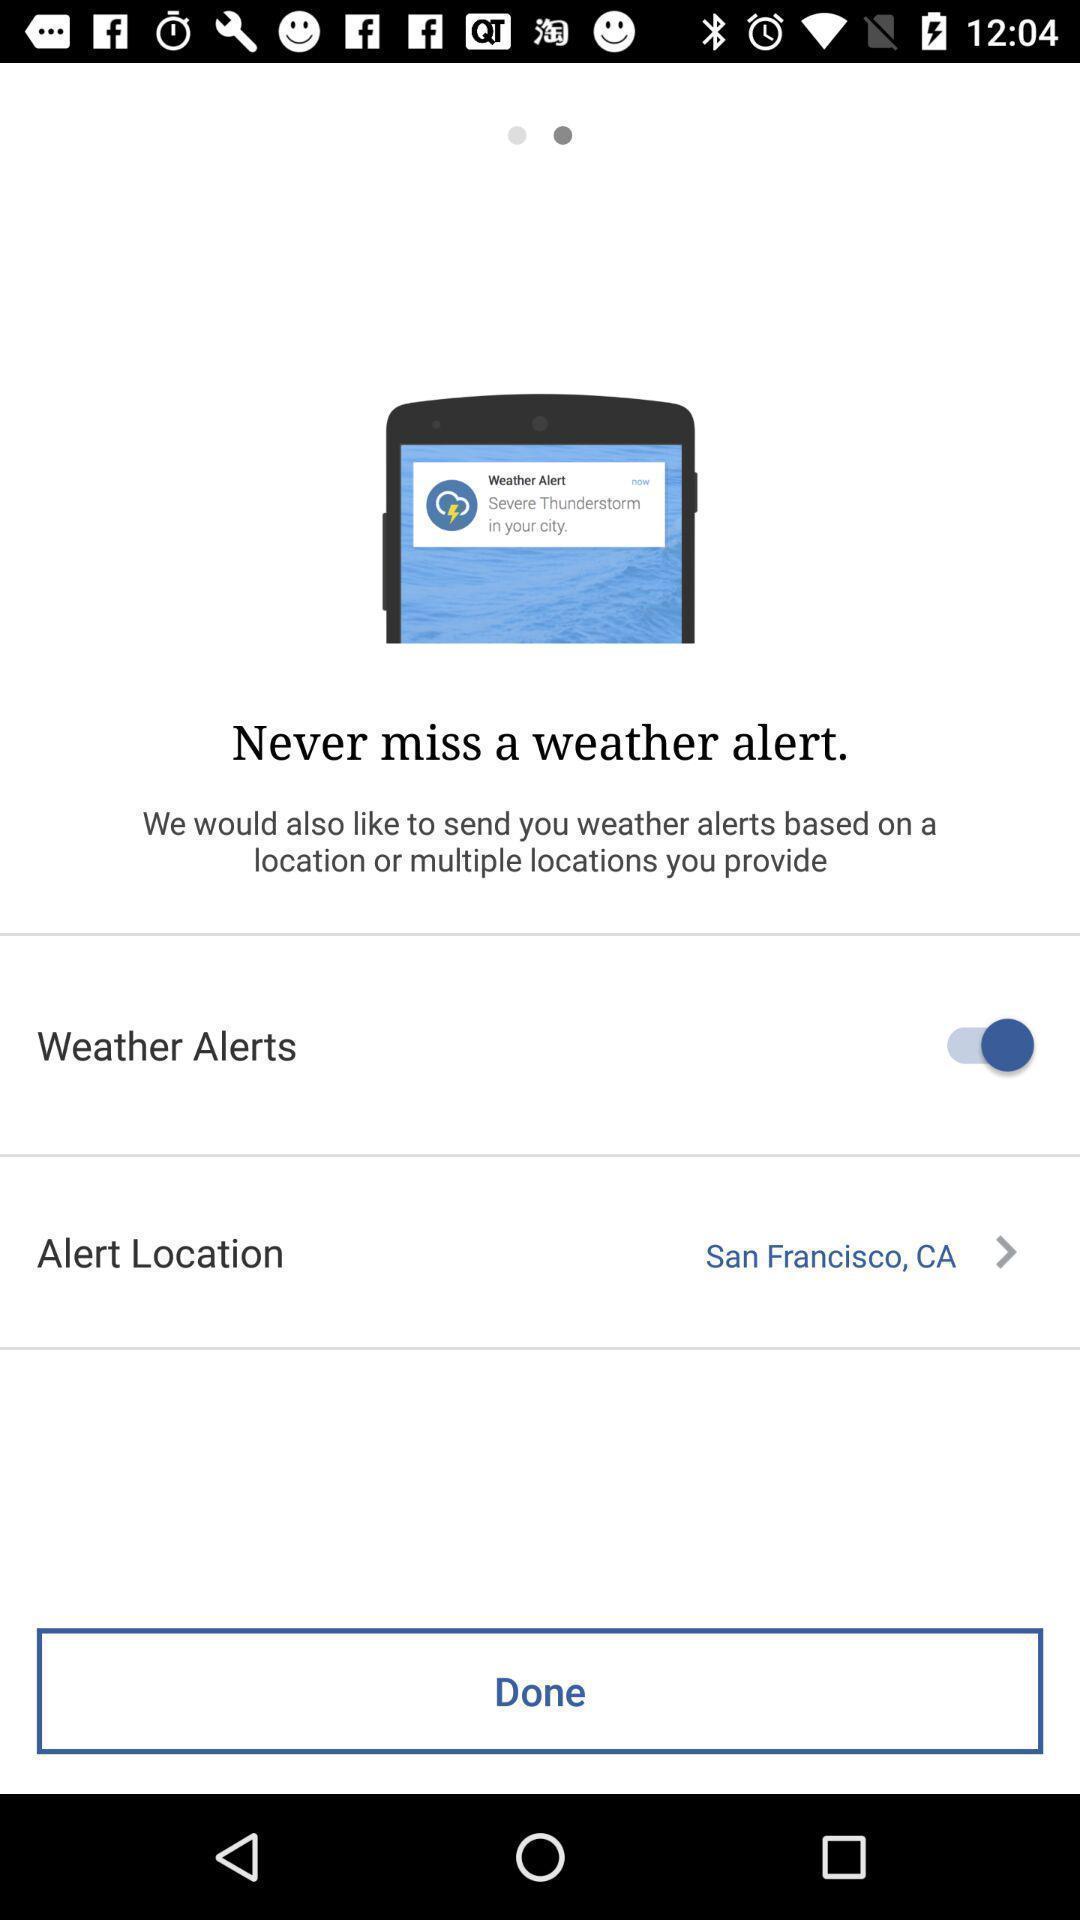Describe the visual elements of this screenshot. Welcome page of a weather app. 